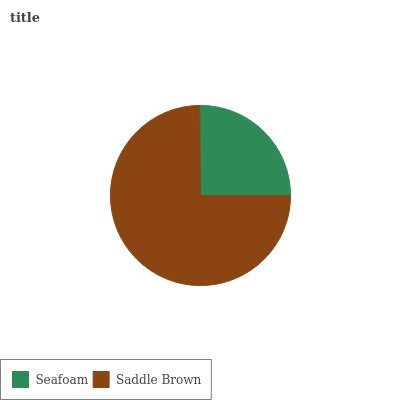Is Seafoam the minimum?
Answer yes or no. Yes. Is Saddle Brown the maximum?
Answer yes or no. Yes. Is Saddle Brown the minimum?
Answer yes or no. No. Is Saddle Brown greater than Seafoam?
Answer yes or no. Yes. Is Seafoam less than Saddle Brown?
Answer yes or no. Yes. Is Seafoam greater than Saddle Brown?
Answer yes or no. No. Is Saddle Brown less than Seafoam?
Answer yes or no. No. Is Saddle Brown the high median?
Answer yes or no. Yes. Is Seafoam the low median?
Answer yes or no. Yes. Is Seafoam the high median?
Answer yes or no. No. Is Saddle Brown the low median?
Answer yes or no. No. 